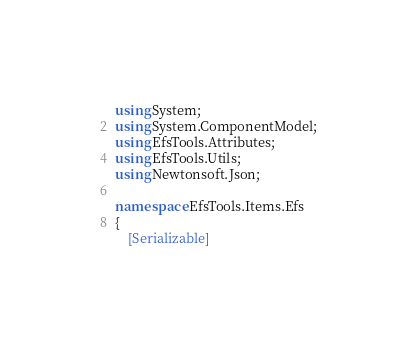<code> <loc_0><loc_0><loc_500><loc_500><_C#_>using System;
using System.ComponentModel;
using EfsTools.Attributes;
using EfsTools.Utils;
using Newtonsoft.Json;

namespace EfsTools.Items.Efs
{
    [Serializable]</code> 